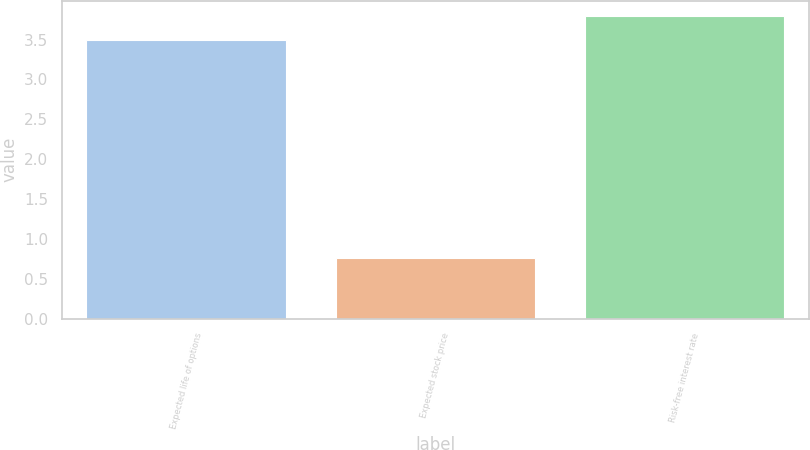Convert chart to OTSL. <chart><loc_0><loc_0><loc_500><loc_500><bar_chart><fcel>Expected life of options<fcel>Expected stock price<fcel>Risk-free interest rate<nl><fcel>3.5<fcel>0.76<fcel>3.8<nl></chart> 